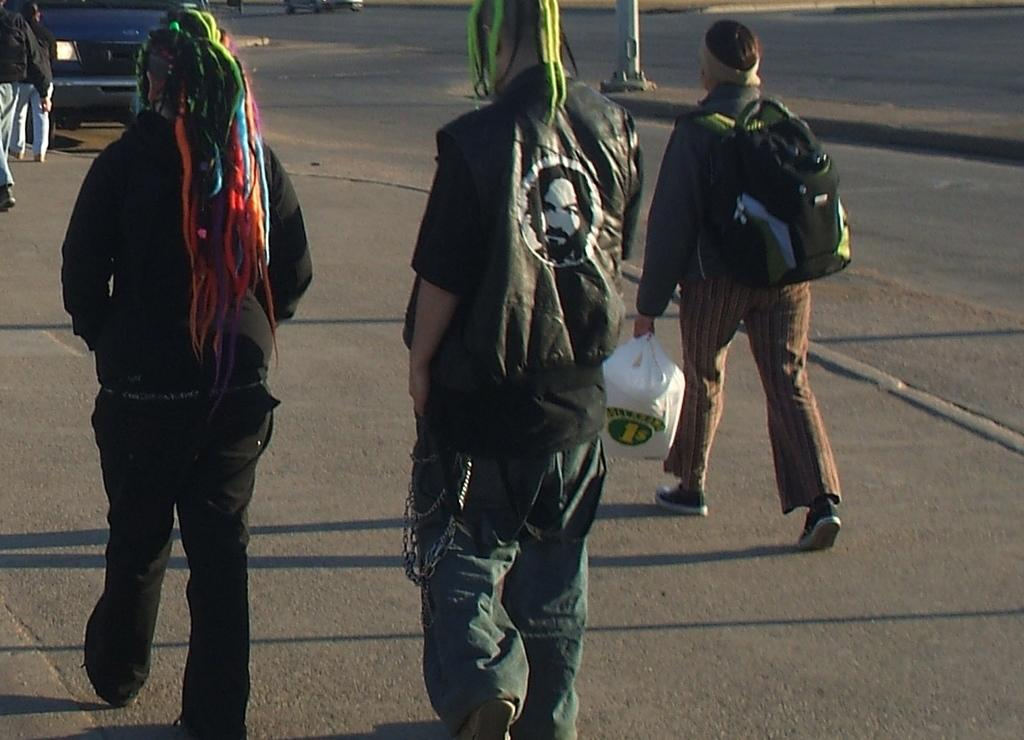What are the people in the image doing? The people in the image are walking on the road. What is in front of the people walking on the road? There is a vehicle in front of the people. What can be seen in the center of the image? There is a pole in the center of the image. What type of friend is sitting on the pole in the image? There is no friend sitting on the pole in the image; there is only a pole visible. 